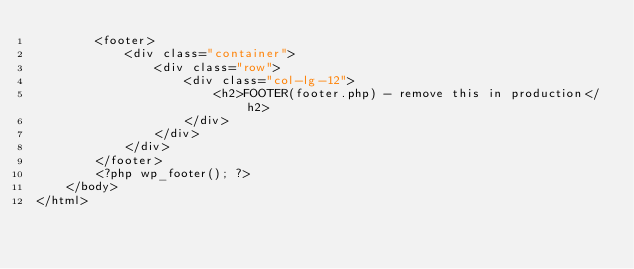Convert code to text. <code><loc_0><loc_0><loc_500><loc_500><_PHP_>        <footer>
            <div class="container">
                <div class="row">
                    <div class="col-lg-12">
                        <h2>FOOTER(footer.php) - remove this in production</h2>
                    </div>  
                </div>
            </div>
        </footer>
        <?php wp_footer(); ?>
    </body>
</html></code> 